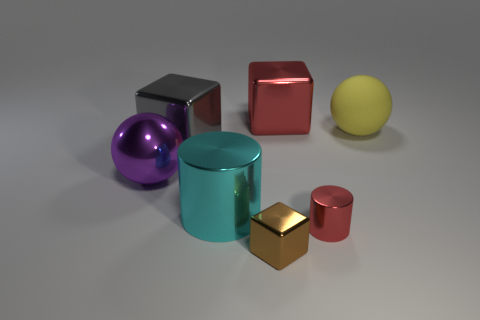Subtract all red metallic blocks. How many blocks are left? 2 Add 3 large purple objects. How many objects exist? 10 Subtract all brown cubes. How many cubes are left? 2 Subtract all blocks. How many objects are left? 4 Subtract all gray cylinders. How many brown cubes are left? 1 Subtract all large gray objects. Subtract all tiny red things. How many objects are left? 5 Add 7 tiny brown cubes. How many tiny brown cubes are left? 8 Add 4 blue objects. How many blue objects exist? 4 Subtract 0 yellow cylinders. How many objects are left? 7 Subtract 1 cylinders. How many cylinders are left? 1 